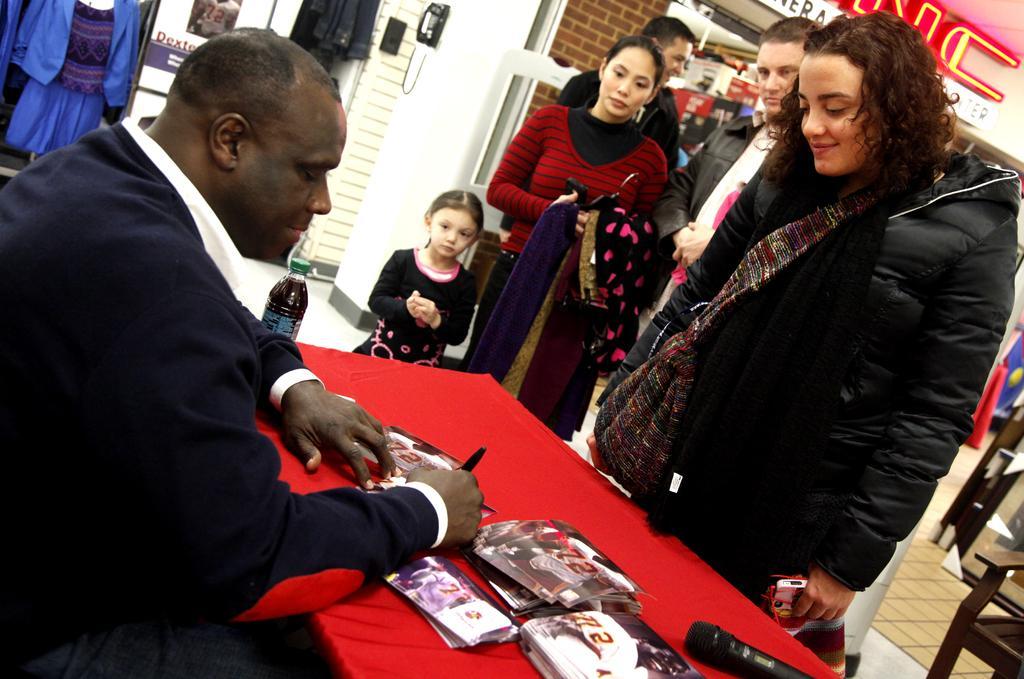In one or two sentences, can you explain what this image depicts? In this picture we can see a man is sitting in front of a table, there are some posters, a bottle and a microphone present on the table, on the right side there are some people standing, it looks like a store in the background, at the left top of the picture we can see clothes, at the right bottom there is a chair, we can see a telephone at the top of the picture. 